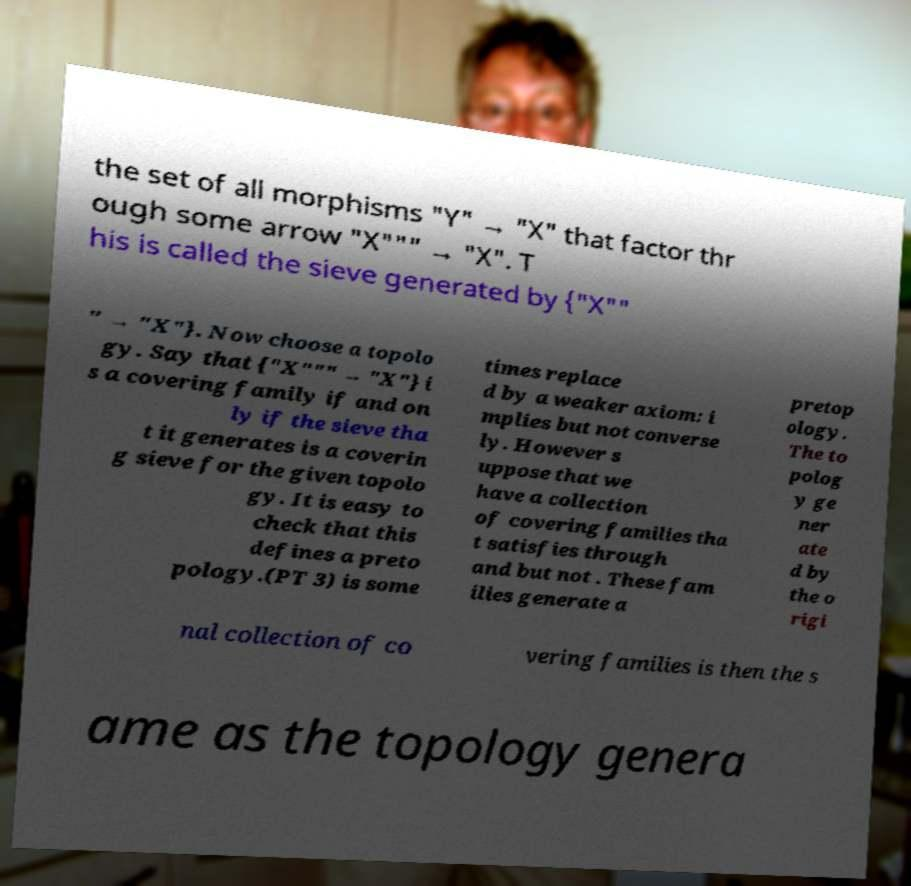I need the written content from this picture converted into text. Can you do that? the set of all morphisms "Y" → "X" that factor thr ough some arrow "X""" → "X". T his is called the sieve generated by {"X"" " → "X"}. Now choose a topolo gy. Say that {"X""" → "X"} i s a covering family if and on ly if the sieve tha t it generates is a coverin g sieve for the given topolo gy. It is easy to check that this defines a preto pology.(PT 3) is some times replace d by a weaker axiom: i mplies but not converse ly. However s uppose that we have a collection of covering families tha t satisfies through and but not . These fam ilies generate a pretop ology. The to polog y ge ner ate d by the o rigi nal collection of co vering families is then the s ame as the topology genera 